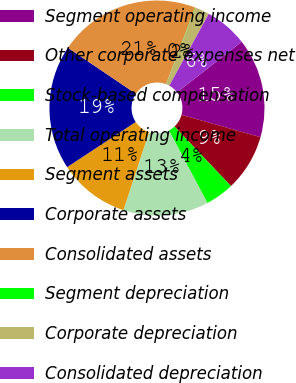Convert chart. <chart><loc_0><loc_0><loc_500><loc_500><pie_chart><fcel>Segment operating income<fcel>Other corporate expenses net<fcel>Stock-based compensation<fcel>Total operating income<fcel>Segment assets<fcel>Corporate assets<fcel>Consolidated assets<fcel>Segment depreciation<fcel>Corporate depreciation<fcel>Consolidated depreciation<nl><fcel>14.94%<fcel>8.56%<fcel>4.31%<fcel>12.81%<fcel>10.69%<fcel>18.72%<fcel>21.32%<fcel>0.05%<fcel>2.18%<fcel>6.43%<nl></chart> 